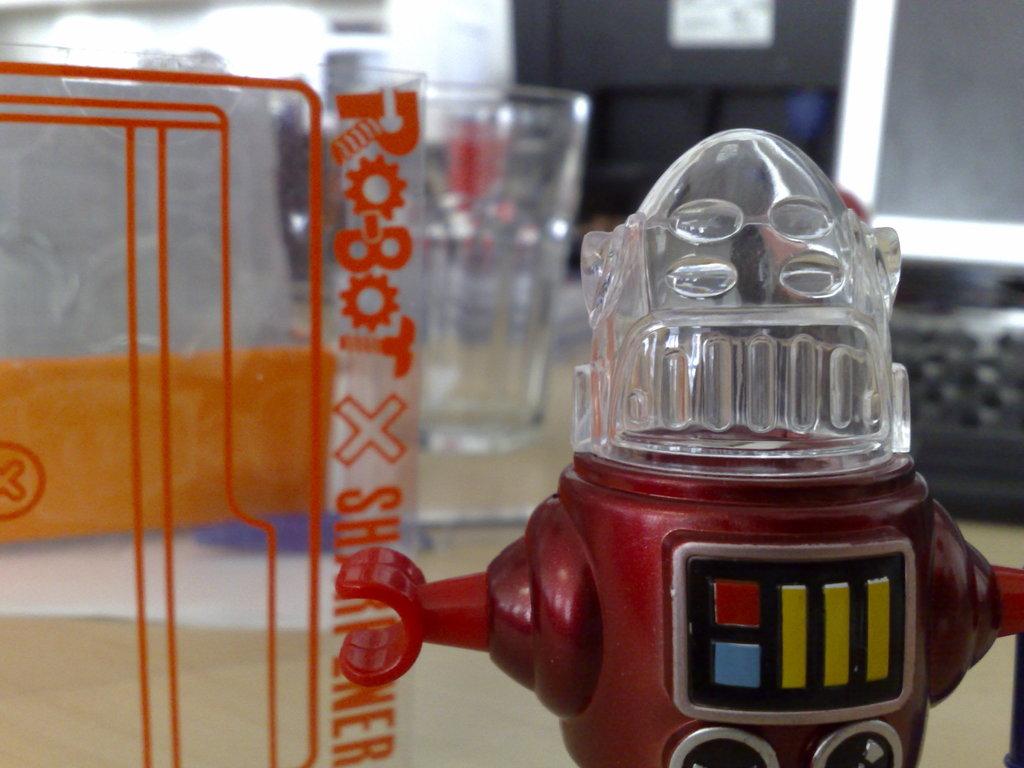What brand is this?
Your response must be concise. Robot x. 